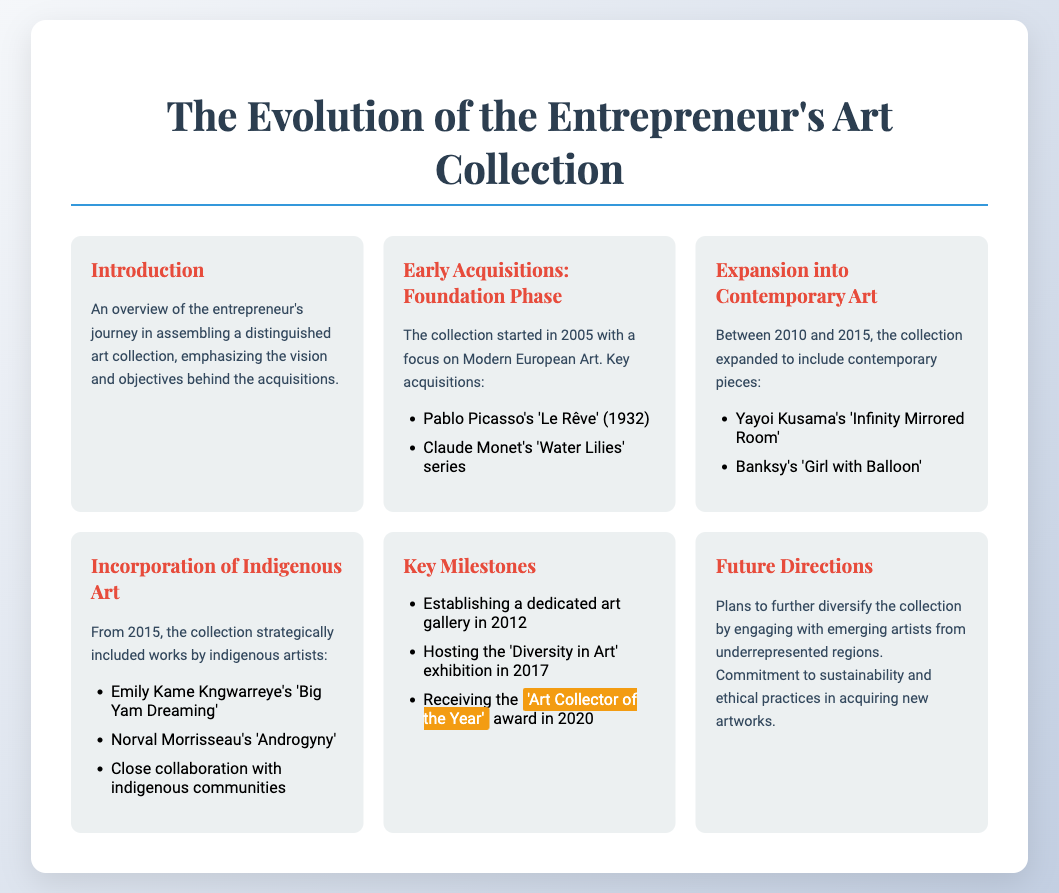What year did the entrepreneur start acquiring art? The entrepreneur began acquiring art in 2005.
Answer: 2005 What is one of the key early acquisitions? A key early acquisition mentioned in the document is 'Le Rêve' by Pablo Picasso.
Answer: 'Le Rêve' Which artist's work is included in the contemporary phase? During the contemporary art expansion, Yayoi Kusama's 'Infinity Mirrored Room' is highlighted.
Answer: 'Infinity Mirrored Room' When was the 'Diversity in Art' exhibition hosted? The 'Diversity in Art' exhibition was hosted in 2017.
Answer: 2017 What award did the entrepreneur receive in 2020? The entrepreneur received the 'Art Collector of the Year' award in 2020.
Answer: 'Art Collector of the Year' What is a focus area for future collection diversification? Future directions include engaging with emerging artists from underrepresented regions.
Answer: Emerging artists Which indigenous artist's work is mentioned in the collection? Emily Kame Kngwarreye's 'Big Yam Dreaming' is mentioned in the collection.
Answer: 'Big Yam Dreaming' What is a significant milestone established in 2012? A dedicated art gallery was established in 2012.
Answer: Dedicated art gallery What type of art did the collection focus on initially? The initial focus of the collection was on Modern European Art.
Answer: Modern European Art 